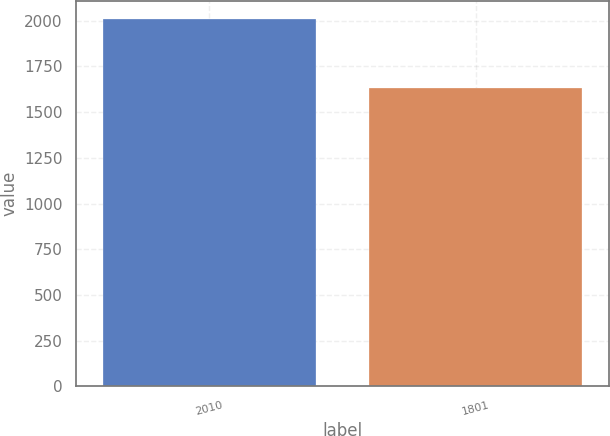Convert chart. <chart><loc_0><loc_0><loc_500><loc_500><bar_chart><fcel>2010<fcel>1801<nl><fcel>2009<fcel>1631<nl></chart> 